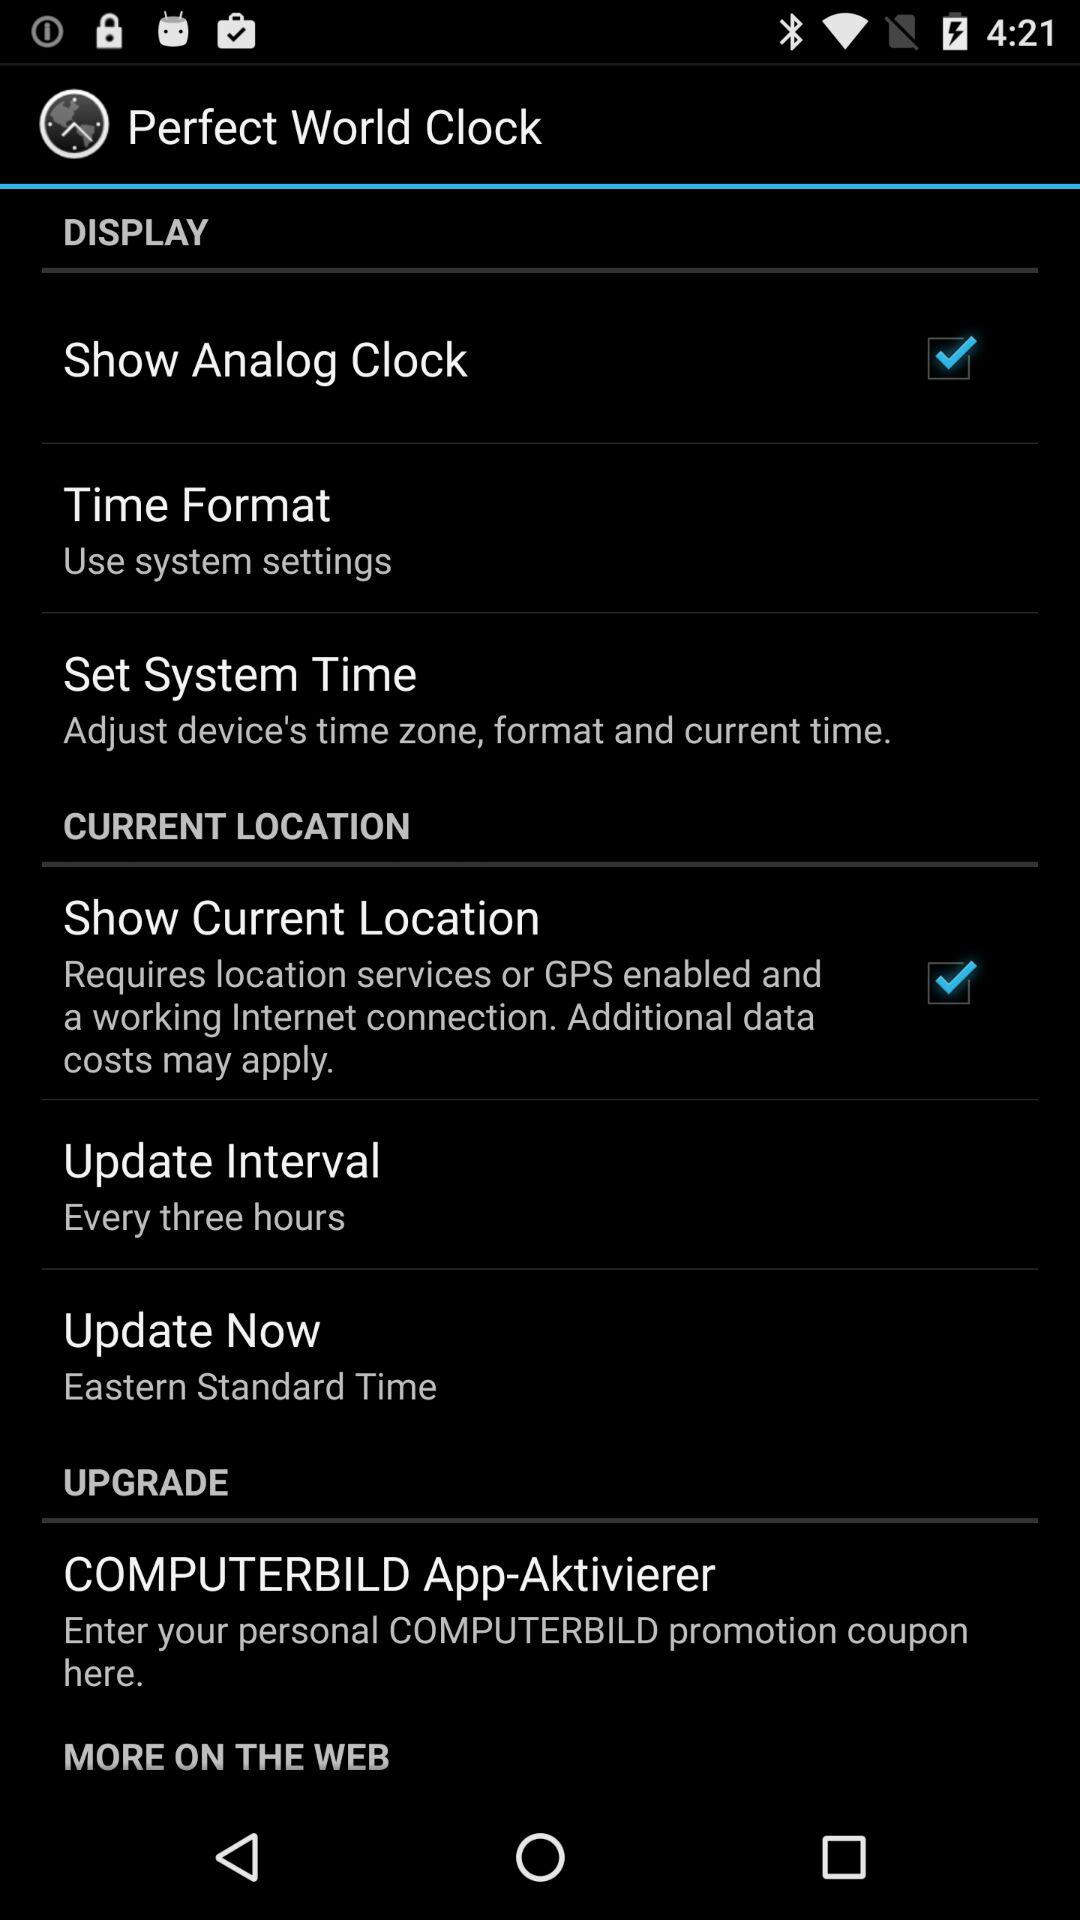What is the checked checkbox? The checked checkboxes are "Show Analog Clock" and "Show Current Location". 